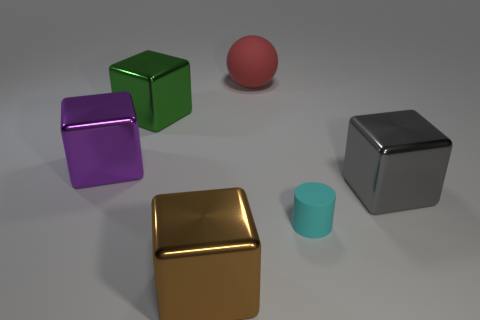Can you tell me more about the golden object? Certainly! The golden object appears to be a cube as well, with a smooth surface that reflects light and gives it a lustrous finish. Its color resembles that of gold, often associated with luxury and high value. 